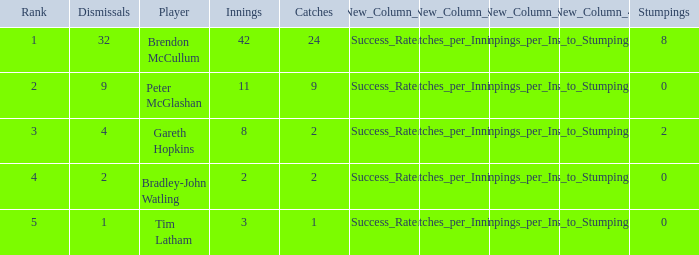How many innings had a total of 2 catches and 0 stumpings? 1.0. 